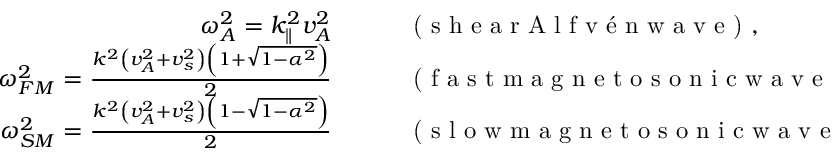Convert formula to latex. <formula><loc_0><loc_0><loc_500><loc_500>\begin{array} { r l } { \omega _ { A } ^ { 2 } = k _ { \| } ^ { 2 } v _ { A } ^ { 2 } \quad } & ( s h e a r A l f v n w a v e ) , } \\ { \omega _ { F M } ^ { 2 } = \frac { k ^ { 2 } \left ( v _ { A } ^ { 2 } + v _ { s } ^ { 2 } \right ) \left ( 1 + \sqrt { 1 - \alpha ^ { 2 } } \right ) } { 2 } \quad } & ( f a s t m a g n e t o s o n i c w a v e ) , } \\ { \omega _ { S M } ^ { 2 } = \frac { k ^ { 2 } \left ( v _ { A } ^ { 2 } + v _ { s } ^ { 2 } \right ) \left ( 1 - \sqrt { 1 - \alpha ^ { 2 } } \right ) } { 2 } \quad } & ( s l o w m a g n e t o s o n i c w a v e ) , } \end{array}</formula> 